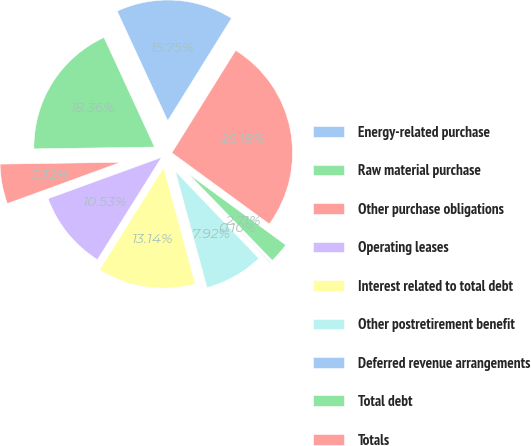Convert chart to OTSL. <chart><loc_0><loc_0><loc_500><loc_500><pie_chart><fcel>Energy-related purchase<fcel>Raw material purchase<fcel>Other purchase obligations<fcel>Operating leases<fcel>Interest related to total debt<fcel>Other postretirement benefit<fcel>Deferred revenue arrangements<fcel>Total debt<fcel>Totals<nl><fcel>15.75%<fcel>18.36%<fcel>5.32%<fcel>10.53%<fcel>13.14%<fcel>7.92%<fcel>0.1%<fcel>2.71%<fcel>26.18%<nl></chart> 